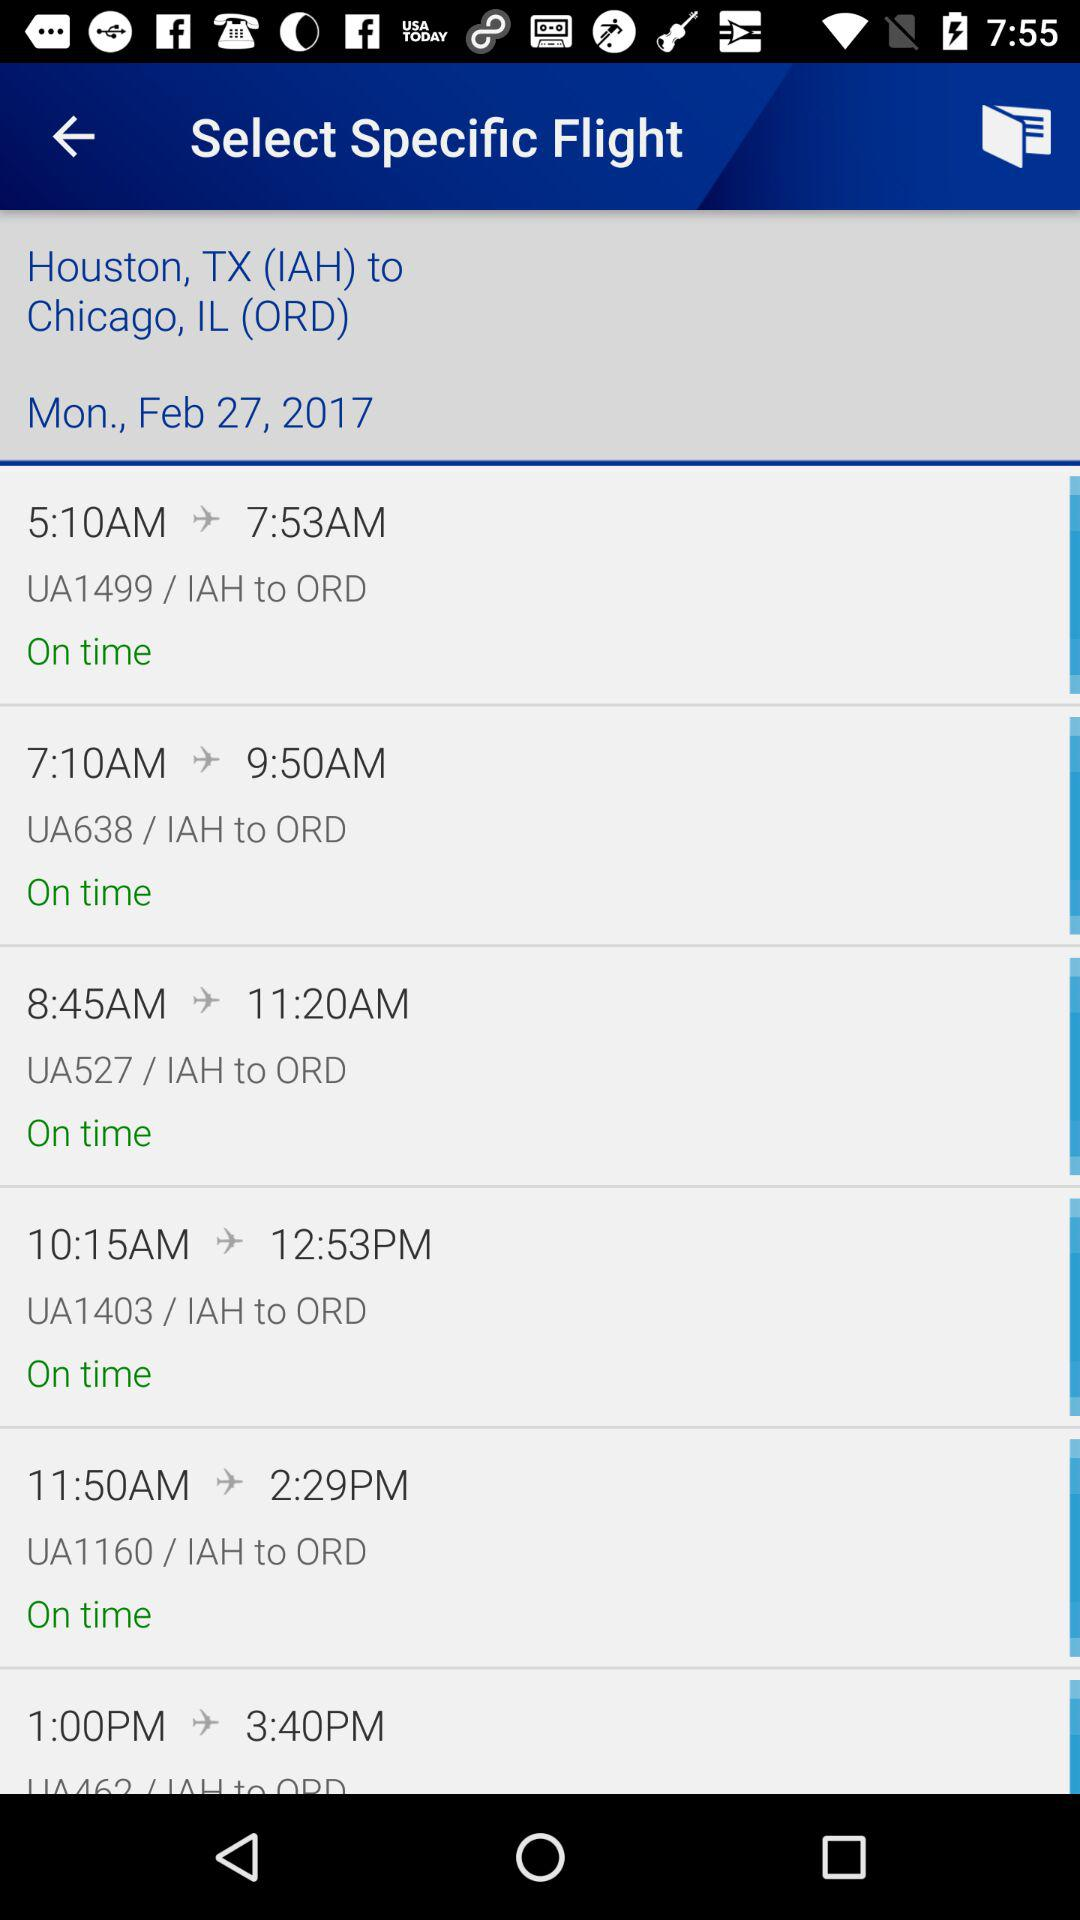Who is this application powered by?
When the provided information is insufficient, respond with <no answer>. <no answer> 